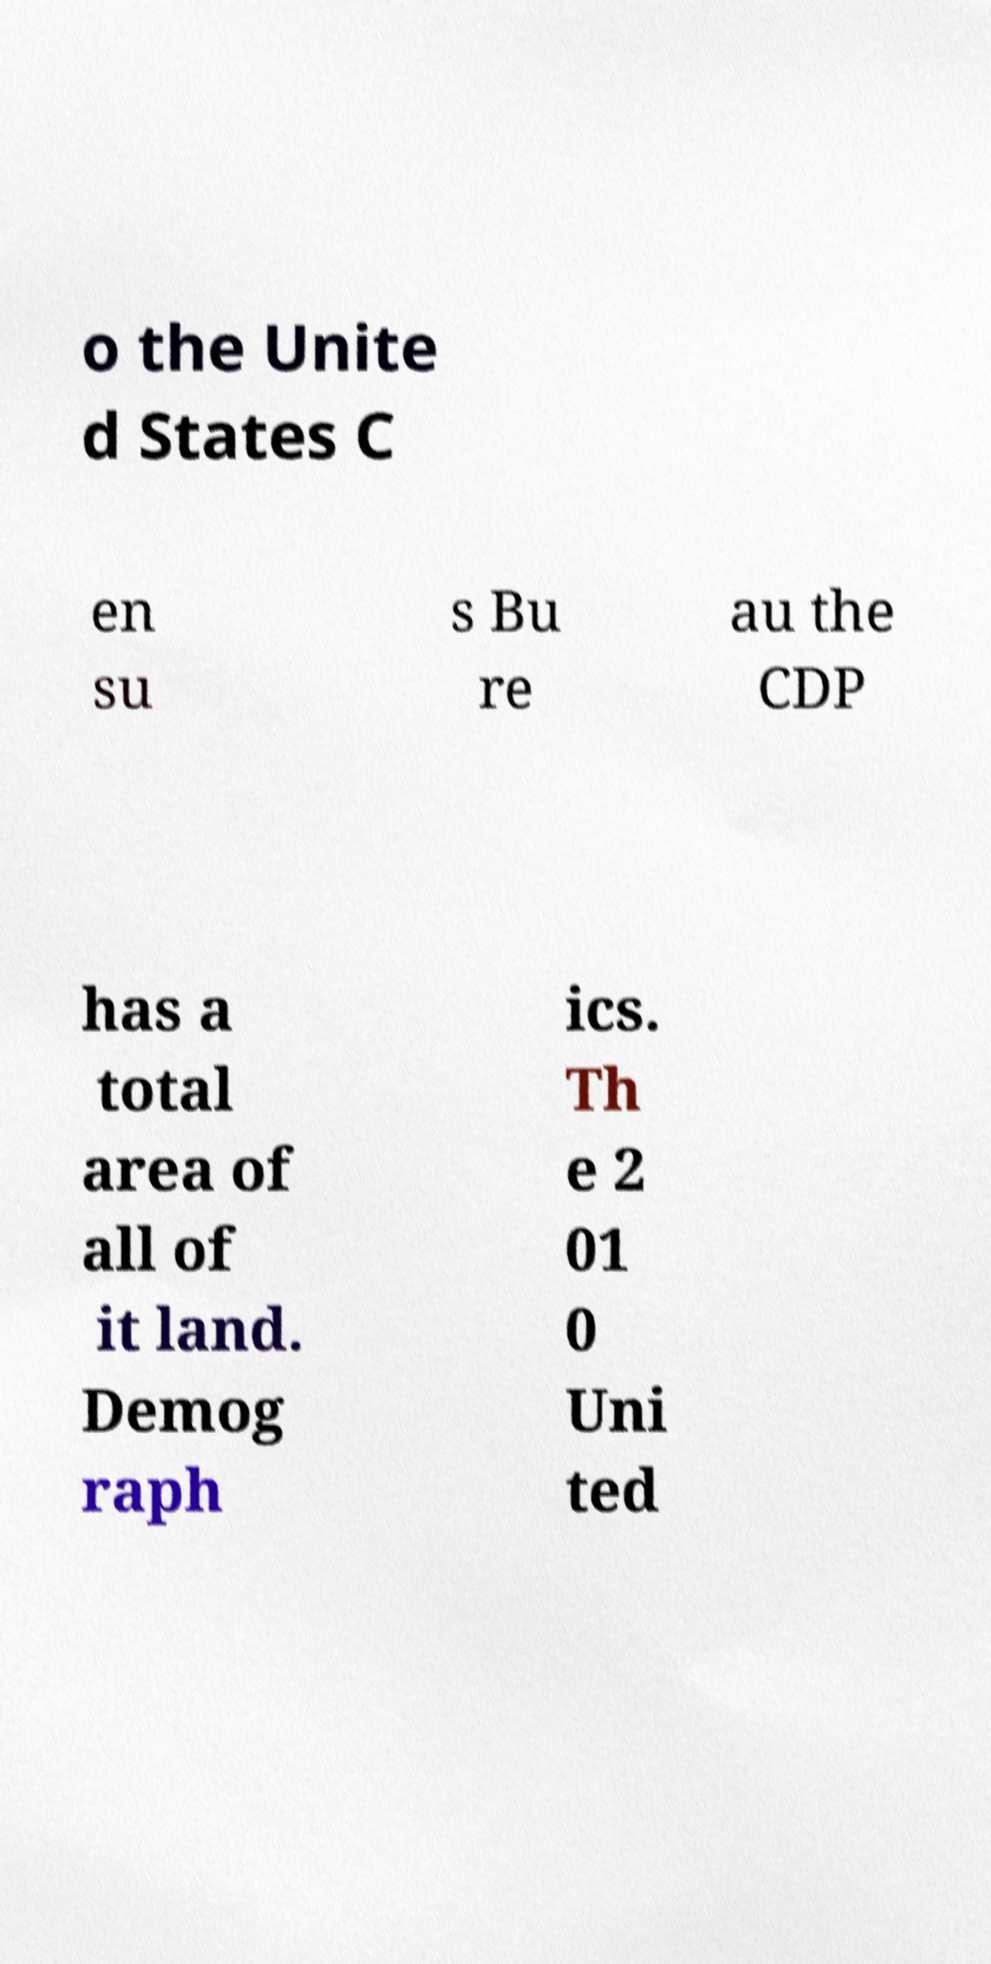For documentation purposes, I need the text within this image transcribed. Could you provide that? o the Unite d States C en su s Bu re au the CDP has a total area of all of it land. Demog raph ics. Th e 2 01 0 Uni ted 